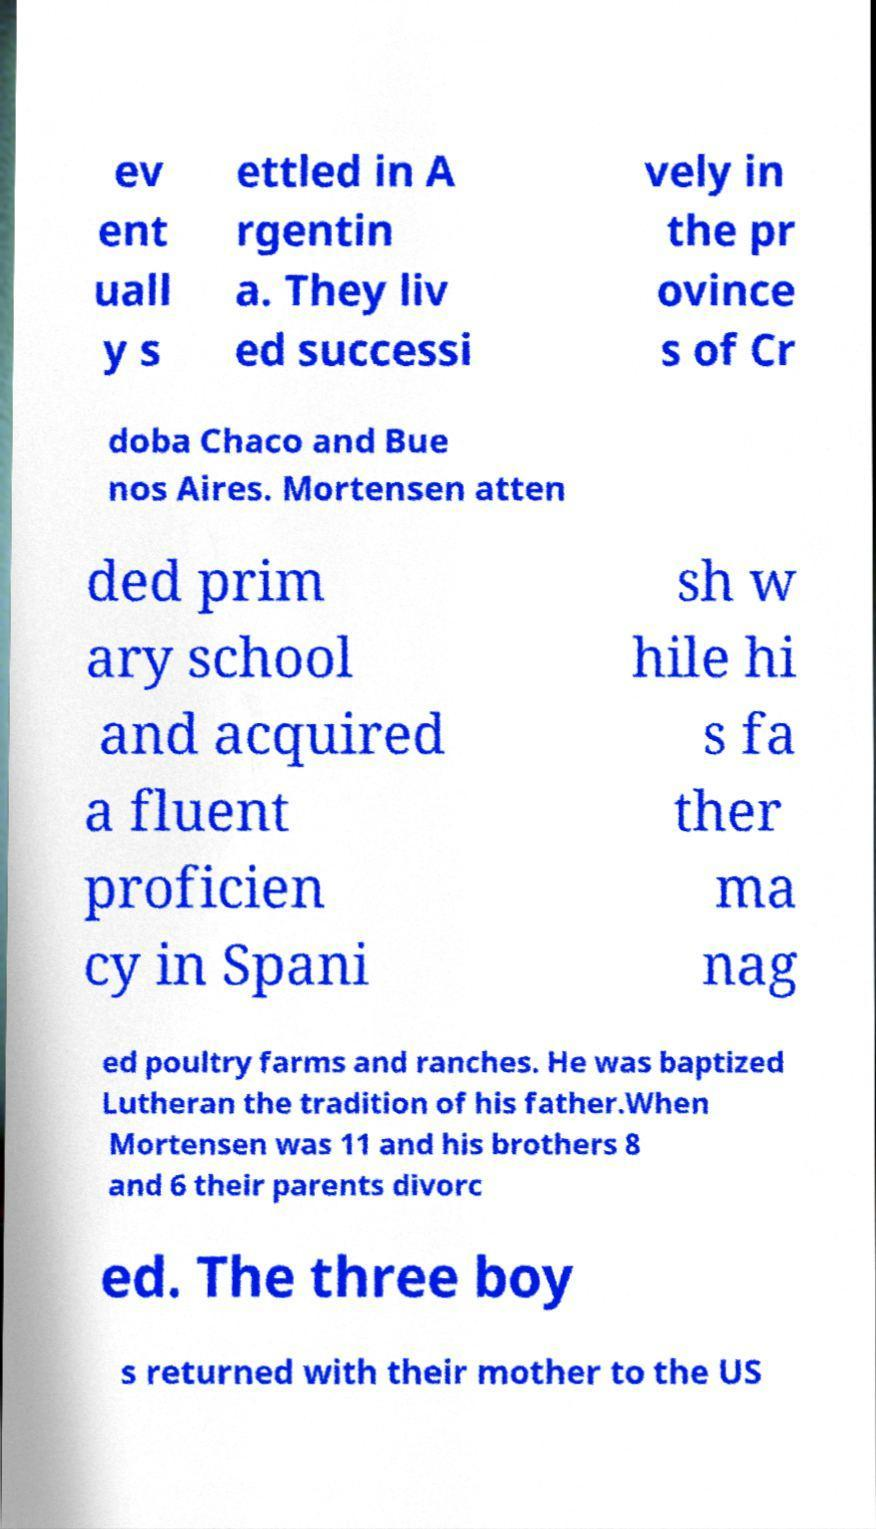Could you extract and type out the text from this image? ev ent uall y s ettled in A rgentin a. They liv ed successi vely in the pr ovince s of Cr doba Chaco and Bue nos Aires. Mortensen atten ded prim ary school and acquired a fluent proficien cy in Spani sh w hile hi s fa ther ma nag ed poultry farms and ranches. He was baptized Lutheran the tradition of his father.When Mortensen was 11 and his brothers 8 and 6 their parents divorc ed. The three boy s returned with their mother to the US 